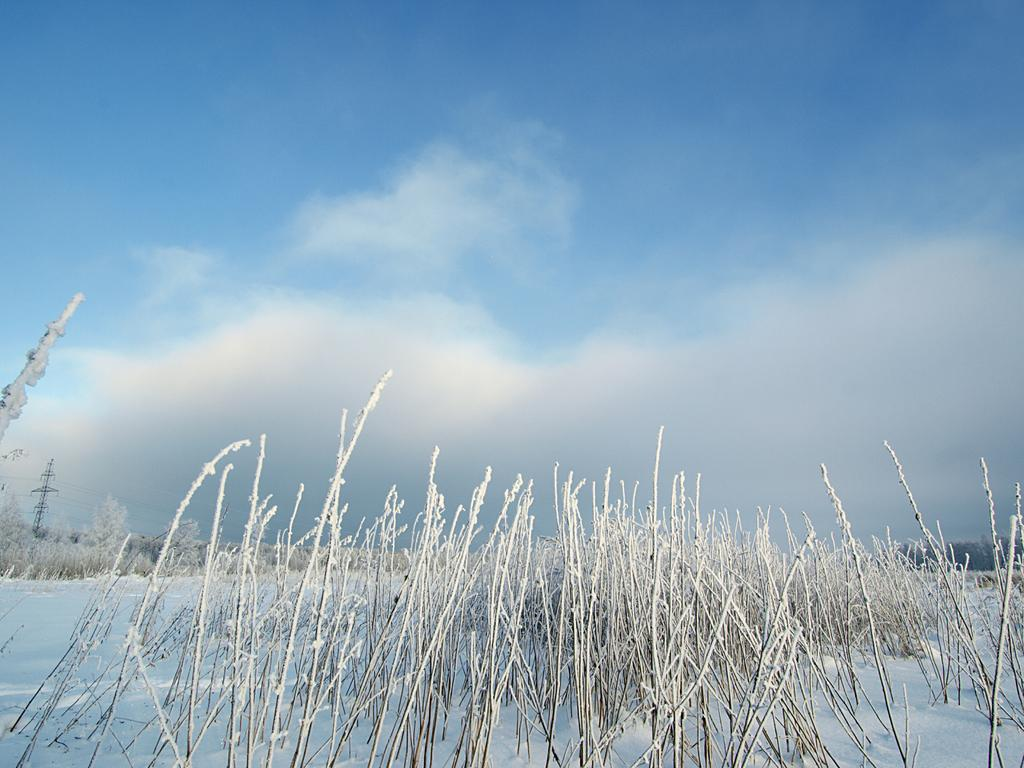What is the predominant weather condition in the image? There is snow in the image, indicating a cold and wintry condition. What type of vegetation can be seen at the bottom of the image? There are plants at the bottom of the image. What is visible in the background of the image? The sky is visible in the image. What can be observed in the sky? Clouds are present in the sky. What type of collar is the maid wearing in the image? There is no maid or collar present in the image. What type of trip can be taken to visit the snowy location in the image? The image does not provide information about the location or how to visit it, so it is not possible to answer this question. 